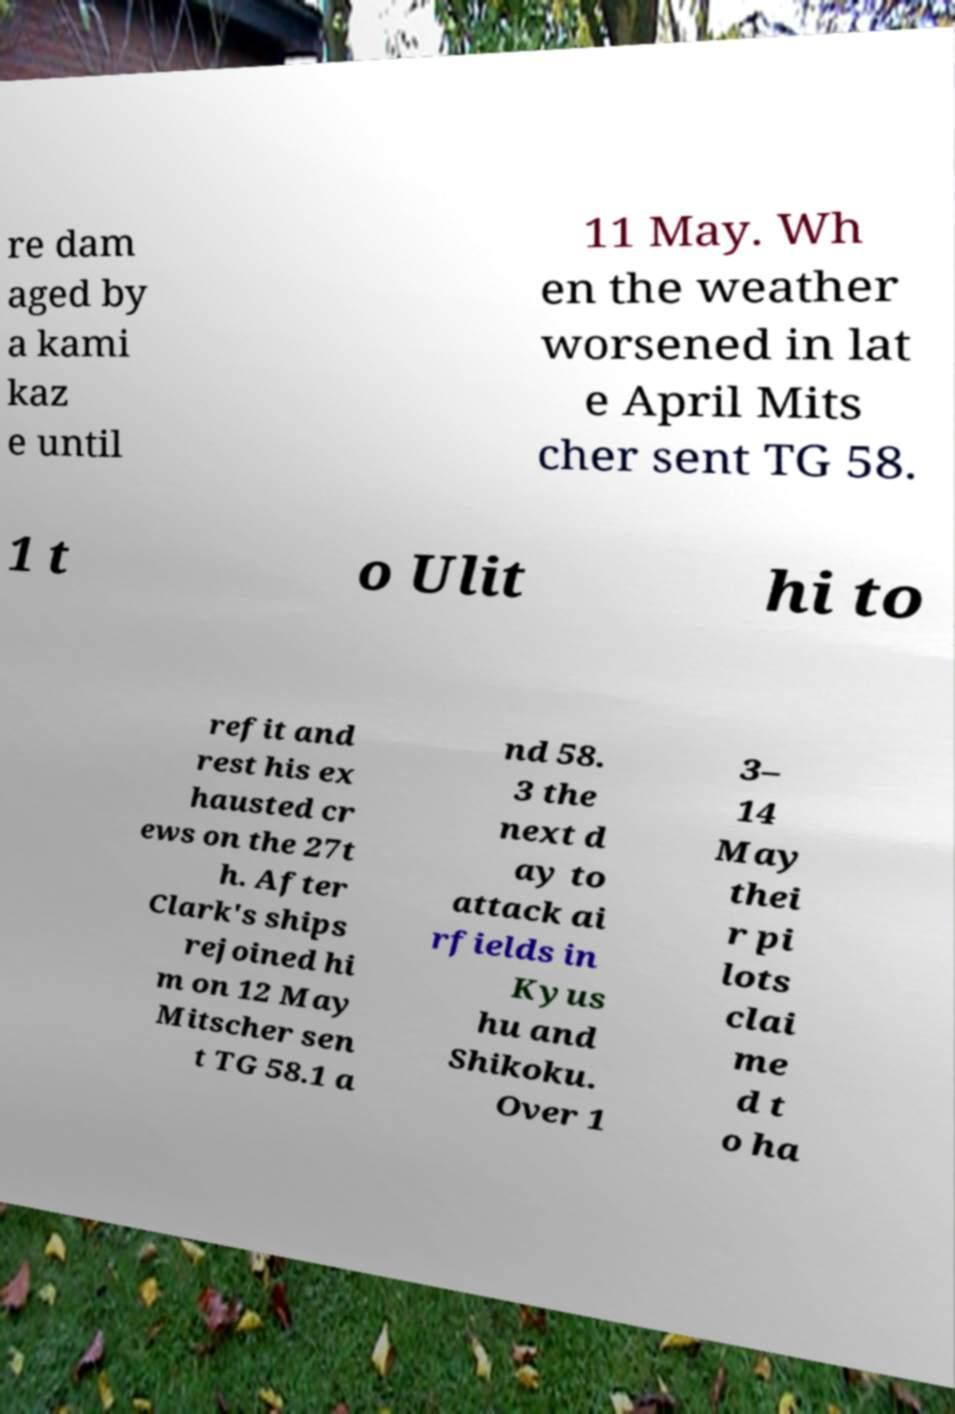Can you accurately transcribe the text from the provided image for me? re dam aged by a kami kaz e until 11 May. Wh en the weather worsened in lat e April Mits cher sent TG 58. 1 t o Ulit hi to refit and rest his ex hausted cr ews on the 27t h. After Clark's ships rejoined hi m on 12 May Mitscher sen t TG 58.1 a nd 58. 3 the next d ay to attack ai rfields in Kyus hu and Shikoku. Over 1 3– 14 May thei r pi lots clai me d t o ha 